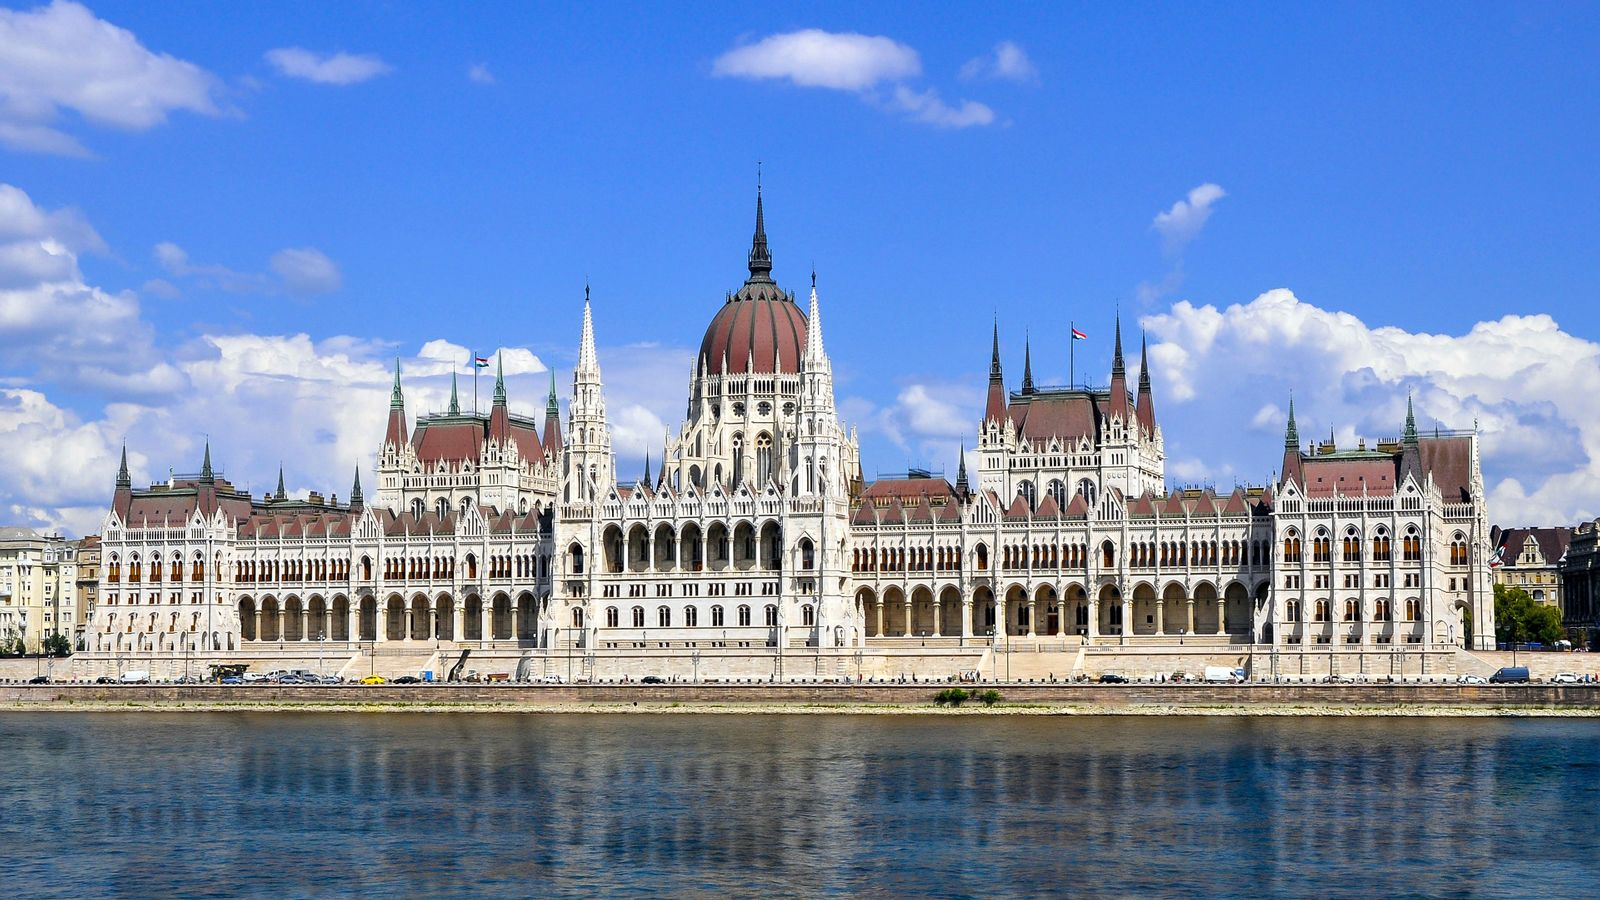In a fantastical twist, imagine a dragon is perched on top of the Parliament Building. Describe the scene. In a fantastical twist, imagine a majestic dragon, with shimmering emerald scales and wings spanning the width of the Parliament Building, perched on top of the central dome. The dragon's scales glint in the sunlight, casting a kaleidoscope of colors onto the building's white facade. Its eyes, glowing with ancient wisdom, survey the city of Budapest below. The dragon's presence adds an otherworldly charm to the historical scene, blending myth with reality. As it unfurls its wings, a gentle breeze sweeps across the Danube River, creating ripples that mirror the dragon's movements. The locals and tourists pause in awe, capturing the moment on their devices, while children gaze in wonder. The sky, once a clear blue, now dances with hues of gold and green from the dragon's luminescent aura. This surreal tableau combines the splendor of architectural achievement with the magic of myth, making the Hungarian Parliament Building a focal point of an extraordinary adventure. 